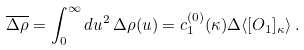<formula> <loc_0><loc_0><loc_500><loc_500>\overline { \Delta \rho } = \int _ { 0 } ^ { \infty } d u ^ { 2 } \, \Delta \rho ( u ) = c _ { 1 } ^ { ( 0 ) } ( \kappa ) \Delta \langle [ O _ { 1 } ] _ { \kappa } \rangle \, .</formula> 